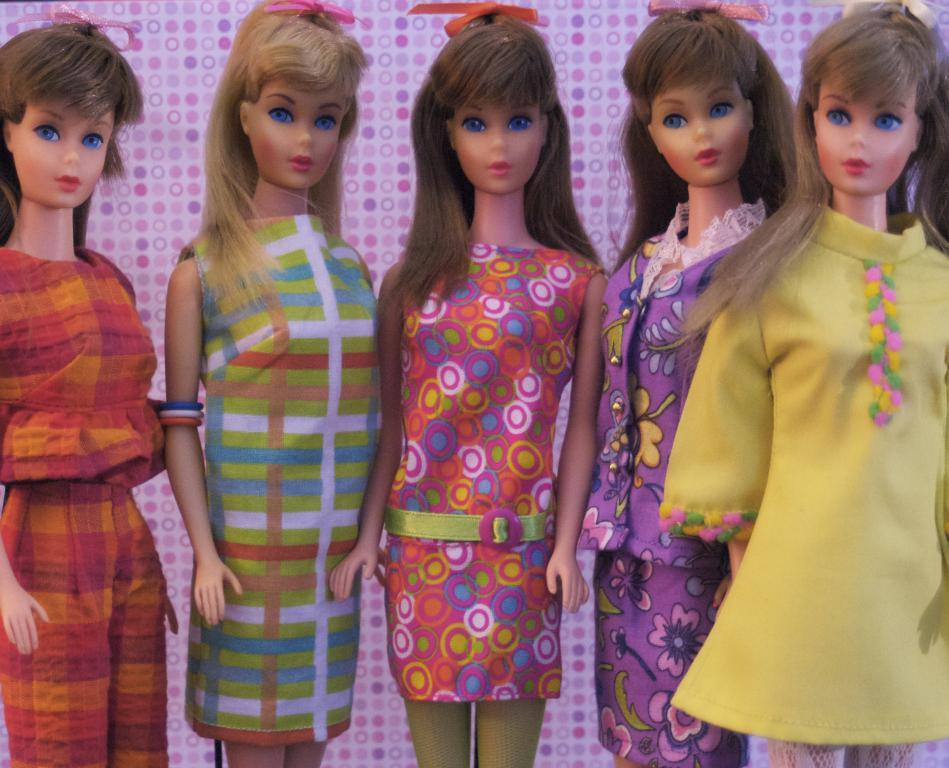What type of dolls are present in the image? There are Barbie dolls in the image. What decision did the egg make for world peace in the image? There is no egg or reference to world peace in the image; it only features Barbie dolls. 